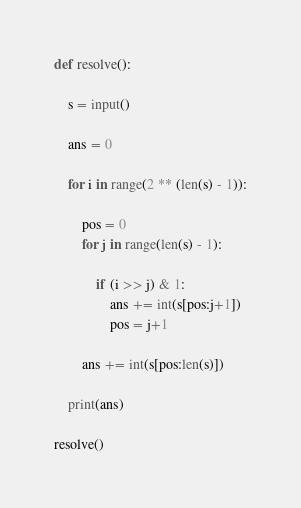<code> <loc_0><loc_0><loc_500><loc_500><_Python_>def resolve():

    s = input()

    ans = 0

    for i in range(2 ** (len(s) - 1)):

        pos = 0
        for j in range(len(s) - 1):

            if (i >> j) & 1:
                ans += int(s[pos:j+1])
                pos = j+1

        ans += int(s[pos:len(s)])

    print(ans)
    
resolve()</code> 